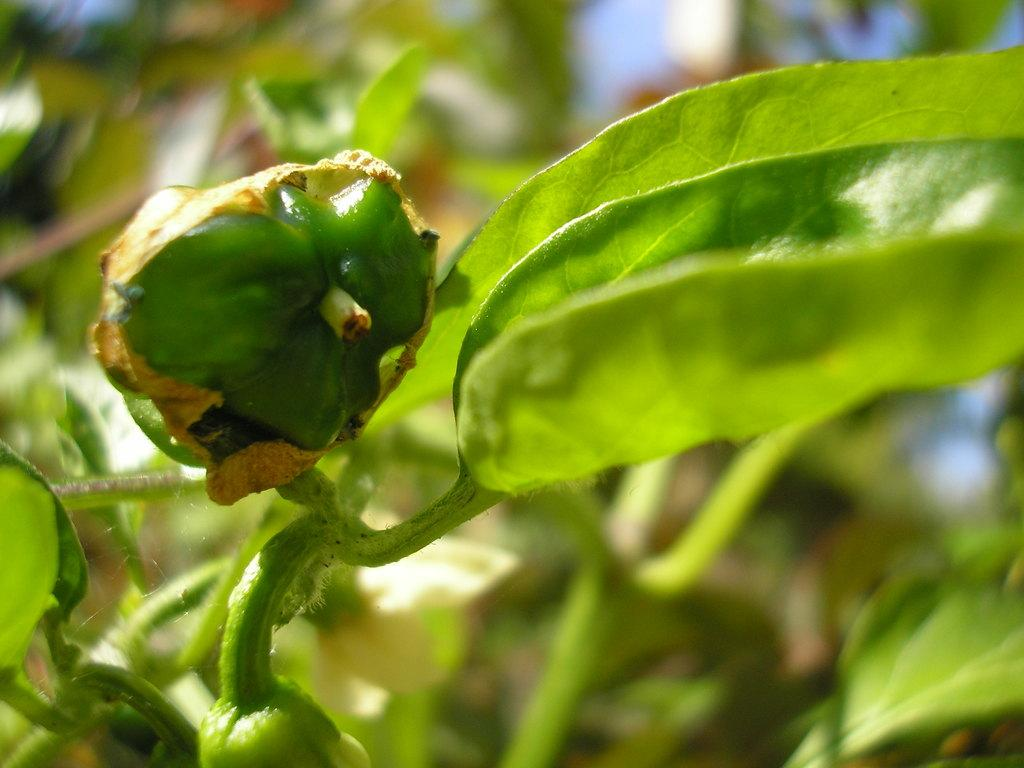What type of plant is visible in the image? There is a plant in the image, but the specific type cannot be determined from the facts provided. What can be seen on the plant in the image? The plant has fruits and leaves. What else is visible in the background of the image? There are other plants in the background of the image. What is the value of the slave depicted in the image? There is no slave present in the image, so it is not possible to determine the value of a slave. 